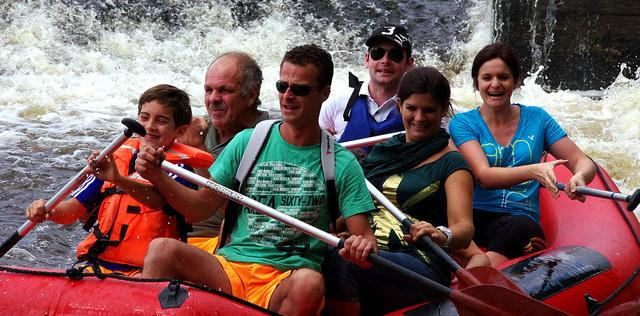What safety item is the person in Green and blue shirts missing?

Choices:
A) life vest
B) bear spray
C) oar
D) whistle life vest 